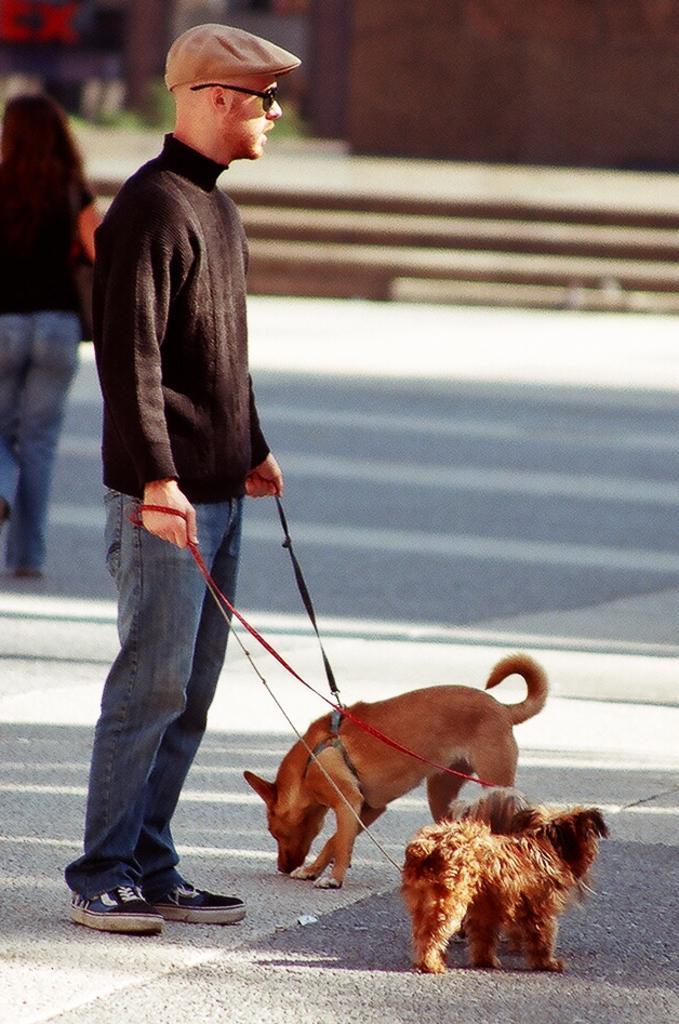How would you summarize this image in a sentence or two? In this picture, In the left side there is a man he is standing and holding two dogs which are in yellow color, In the background there is a woman she is walking and there are some stairs in brown color. 